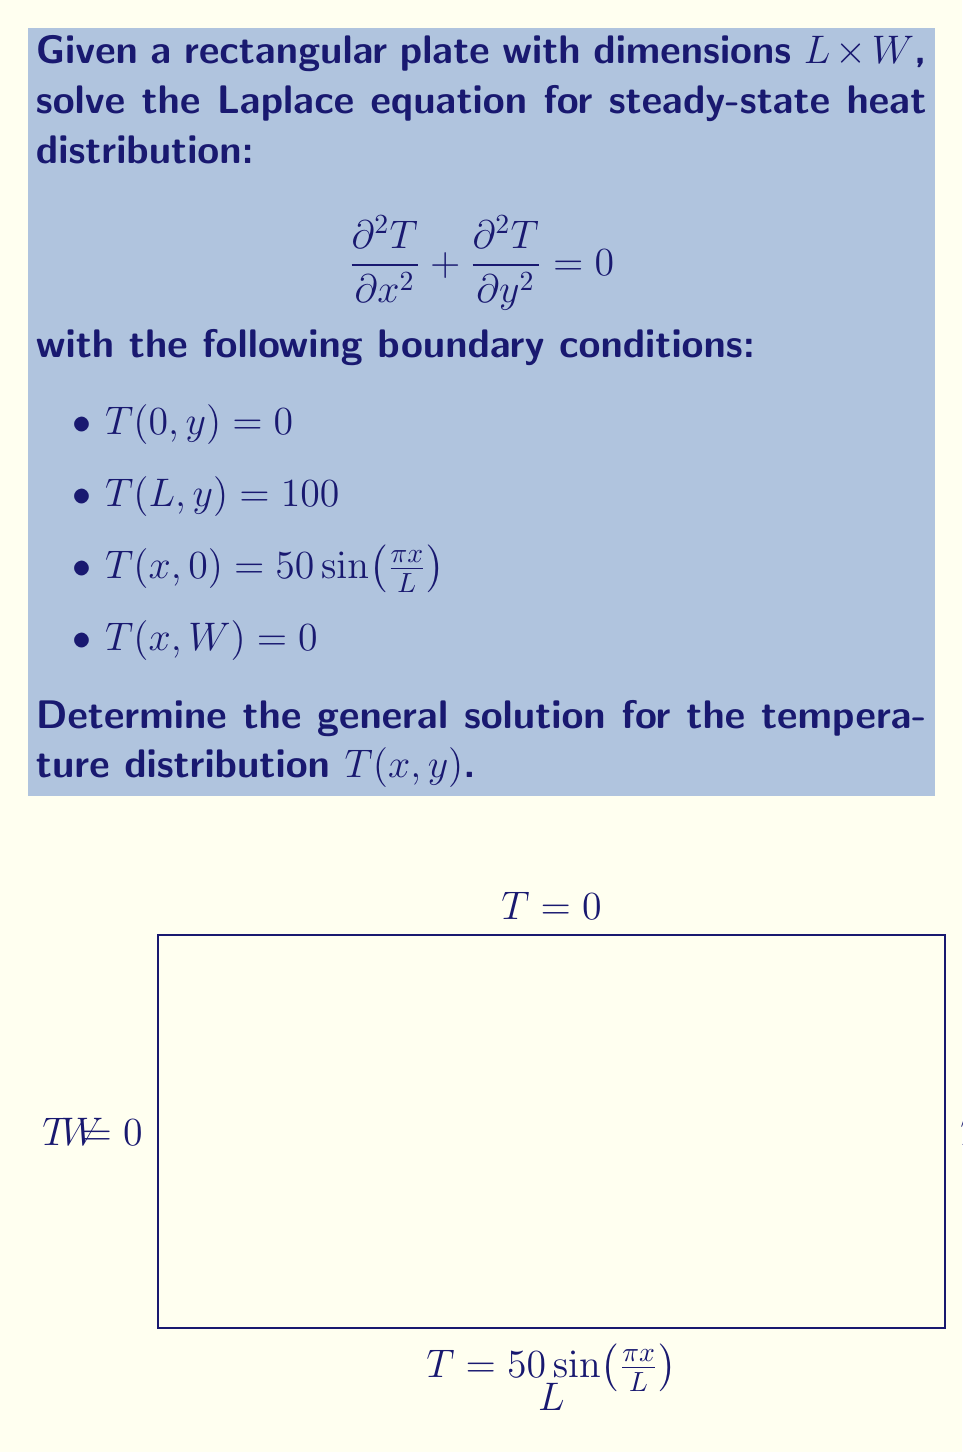Could you help me with this problem? To solve this problem, we'll use the separation of variables method:

1) Assume the solution has the form: $T(x,y) = X(x)Y(y)$

2) Substitute into the Laplace equation:
   $$X''(x)Y(y) + X(x)Y''(y) = 0$$
   $$\frac{X''(x)}{X(x)} = -\frac{Y''(y)}{Y(y)} = -\lambda^2$$

3) This gives two ordinary differential equations:
   $$X''(x) + \lambda^2 X(x) = 0$$
   $$Y''(y) - \lambda^2 Y(y) = 0$$

4) The general solutions are:
   $$X(x) = A\cos(\lambda x) + B\sin(\lambda x)$$
   $$Y(y) = Ce^{\lambda y} + De^{-\lambda y}$$

5) Apply the boundary conditions:
   - $T(0, y) = 0$ implies $A = 0$
   - $T(L, y) = 100$ implies $\sin(\lambda L) = 0$, so $\lambda_n = \frac{n\pi}{L}$
   - $T(x, W) = 0$ implies $C = -D$

6) The general solution becomes:
   $$T(x,y) = \sum_{n=1}^{\infty} (C_n e^{\frac{n\pi y}{L}} - C_n e^{-\frac{n\pi y}{L}}) \sin(\frac{n\pi x}{L})$$

7) Apply the final boundary condition:
   $$T(x, 0) = 50\sin(\frac{\pi x}{L}) = \sum_{n=1}^{\infty} 2C_n \sinh(\frac{n\pi W}{L}) \sin(\frac{n\pi x}{L})$$

8) This implies that only $n=1$ term is non-zero, and:
   $$C_1 = \frac{25}{\sinh(\frac{\pi W}{L})}$$

Therefore, the final solution is:
$$T(x,y) = \frac{25}{\sinh(\frac{\pi W}{L})} (\sinh(\frac{\pi y}{L}) - \sinh(\frac{\pi(W-y)}{L})) \sin(\frac{\pi x}{L})$$
Answer: $$T(x,y) = \frac{25}{\sinh(\frac{\pi W}{L})} (\sinh(\frac{\pi y}{L}) - \sinh(\frac{\pi(W-y)}{L})) \sin(\frac{\pi x}{L})$$ 